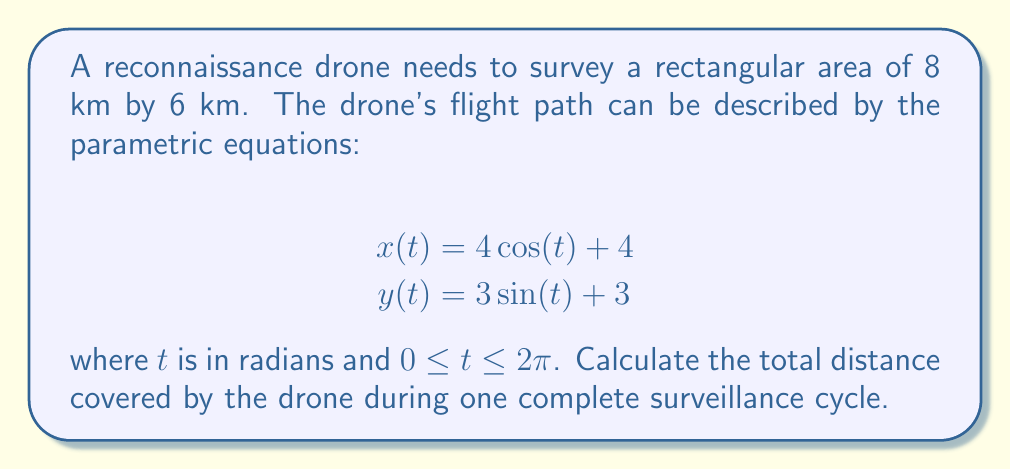Can you solve this math problem? To find the total distance covered by the drone, we need to calculate the arc length of the parametric curve over the given interval. The formula for arc length is:

$$L = \int_a^b \sqrt{\left(\frac{dx}{dt}\right)^2 + \left(\frac{dy}{dt}\right)^2} dt$$

Step 1: Find $\frac{dx}{dt}$ and $\frac{dy}{dt}$
$$\frac{dx}{dt} = -4\sin(t)$$
$$\frac{dy}{dt} = 3\cos(t)$$

Step 2: Substitute into the arc length formula
$$L = \int_0^{2\pi} \sqrt{(-4\sin(t))^2 + (3\cos(t))^2} dt$$

Step 3: Simplify the expression under the square root
$$L = \int_0^{2\pi} \sqrt{16\sin^2(t) + 9\cos^2(t)} dt$$

Step 4: Use the trigonometric identity $\sin^2(t) + \cos^2(t) = 1$
$$L = \int_0^{2\pi} \sqrt{16\sin^2(t) + 9(1-\sin^2(t))} dt$$
$$L = \int_0^{2\pi} \sqrt{16\sin^2(t) + 9 - 9\sin^2(t)} dt$$
$$L = \int_0^{2\pi} \sqrt{7\sin^2(t) + 9} dt$$

Step 5: This integral doesn't have an elementary antiderivative. We can use numerical integration or recognize that this is the formula for the perimeter of an ellipse with semi-major axis 4 km and semi-minor axis 3 km.

The exact formula for the perimeter of an ellipse is:

$$L = 4a\int_0^{\pi/2} \sqrt{1-e^2\sin^2(t)} dt$$

where $a$ is the semi-major axis and $e$ is the eccentricity, given by $e = \sqrt{1-\frac{b^2}{a^2}}$ where $b$ is the semi-minor axis.

In this case, $a=4$, $b=3$, and $e = \sqrt{1-\frac{3^2}{4^2}} = \frac{\sqrt{7}}{4}$

Step 6: Using numerical integration or elliptic integrals, we can calculate the result to be approximately 22.1 km.
Answer: 22.1 km 